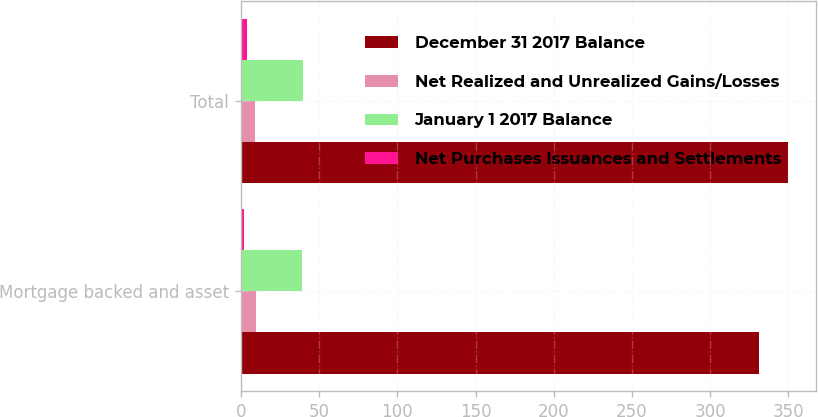<chart> <loc_0><loc_0><loc_500><loc_500><stacked_bar_chart><ecel><fcel>Mortgage backed and asset<fcel>Total<nl><fcel>December 31 2017 Balance<fcel>331<fcel>350<nl><fcel>Net Realized and Unrealized Gains/Losses<fcel>10<fcel>9<nl><fcel>January 1 2017 Balance<fcel>39<fcel>40<nl><fcel>Net Purchases Issuances and Settlements<fcel>2<fcel>4<nl></chart> 